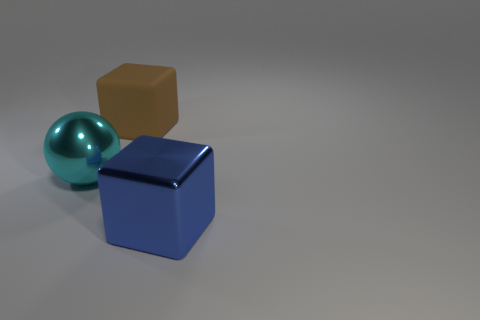Do the cyan metallic object and the big brown object have the same shape?
Make the answer very short. No. What color is the sphere that is the same size as the shiny block?
Provide a succinct answer. Cyan. How many other objects are the same shape as the cyan shiny thing?
Keep it short and to the point. 0. There is a object that is behind the large shiny ball; what is its size?
Offer a terse response. Large. There is a big metallic thing that is right of the large matte object; how many large cubes are behind it?
Keep it short and to the point. 1. Do the big rubber cube and the large ball have the same color?
Ensure brevity in your answer.  No. Does the object in front of the big metallic ball have the same shape as the big brown object?
Make the answer very short. Yes. What number of big blocks are in front of the big metal ball and behind the blue metal block?
Provide a short and direct response. 0. What is the big blue thing made of?
Offer a very short reply. Metal. Is there any other thing that is the same color as the large rubber block?
Offer a terse response. No. 